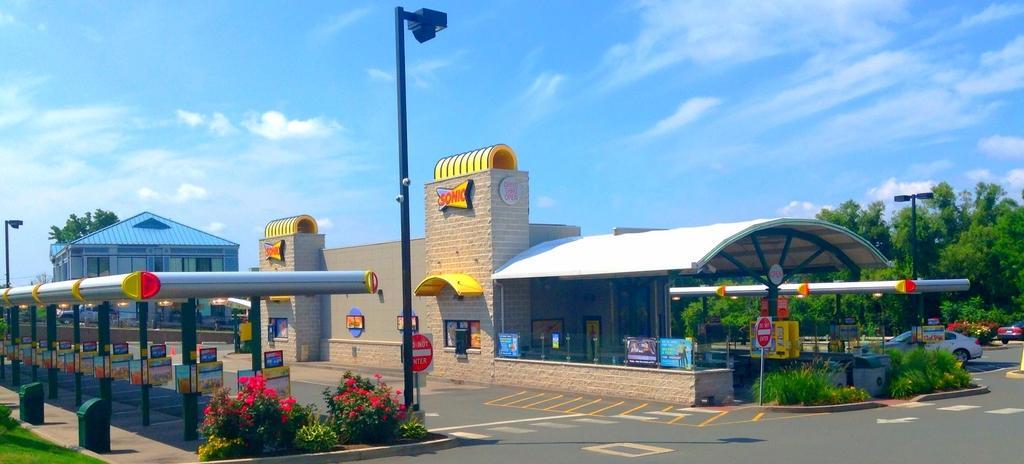Could you give a brief overview of what you see in this image? In this image we can see the building, house, trees and also the light poles and sign boards. We can also see the plants, grass, boards and also the road. On the left we can see the roof for shelter. We can also see the pillars with the boards. We can see the path, flower plants. Image also consists of the vehicles. In the background we can see the sky with some clouds. 